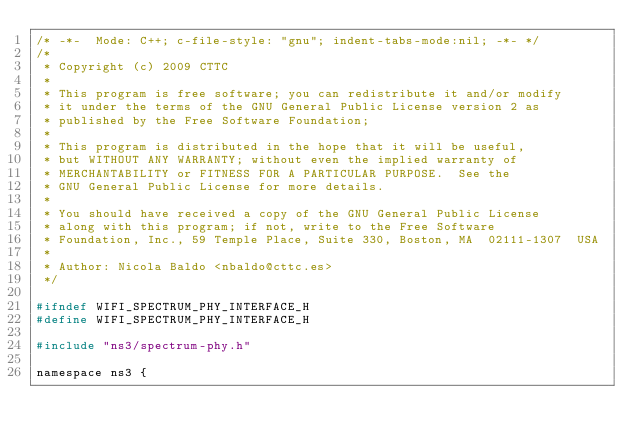<code> <loc_0><loc_0><loc_500><loc_500><_C_>/* -*-  Mode: C++; c-file-style: "gnu"; indent-tabs-mode:nil; -*- */
/*
 * Copyright (c) 2009 CTTC
 *
 * This program is free software; you can redistribute it and/or modify
 * it under the terms of the GNU General Public License version 2 as
 * published by the Free Software Foundation;
 *
 * This program is distributed in the hope that it will be useful,
 * but WITHOUT ANY WARRANTY; without even the implied warranty of
 * MERCHANTABILITY or FITNESS FOR A PARTICULAR PURPOSE.  See the
 * GNU General Public License for more details.
 *
 * You should have received a copy of the GNU General Public License
 * along with this program; if not, write to the Free Software
 * Foundation, Inc., 59 Temple Place, Suite 330, Boston, MA  02111-1307  USA
 *
 * Author: Nicola Baldo <nbaldo@cttc.es>
 */

#ifndef WIFI_SPECTRUM_PHY_INTERFACE_H
#define WIFI_SPECTRUM_PHY_INTERFACE_H

#include "ns3/spectrum-phy.h"

namespace ns3 {
</code> 